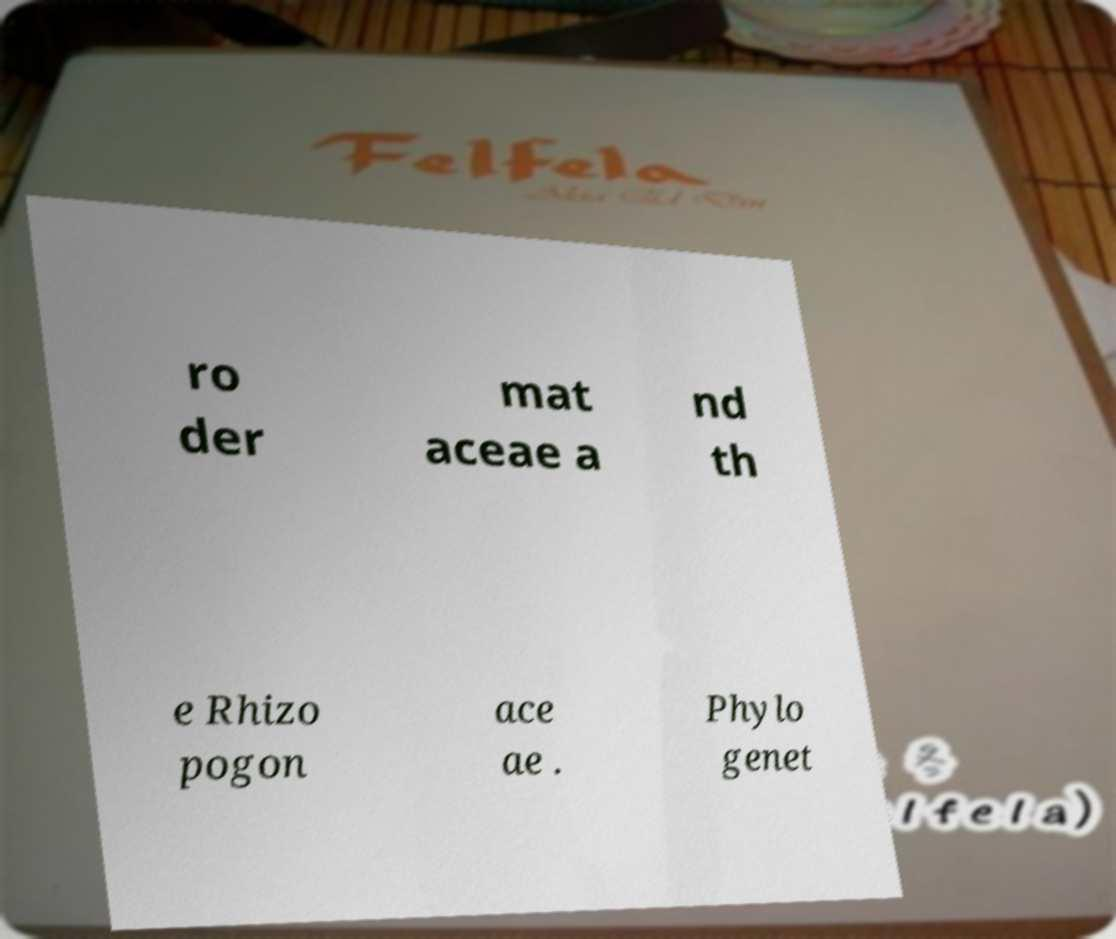What messages or text are displayed in this image? I need them in a readable, typed format. ro der mat aceae a nd th e Rhizo pogon ace ae . Phylo genet 